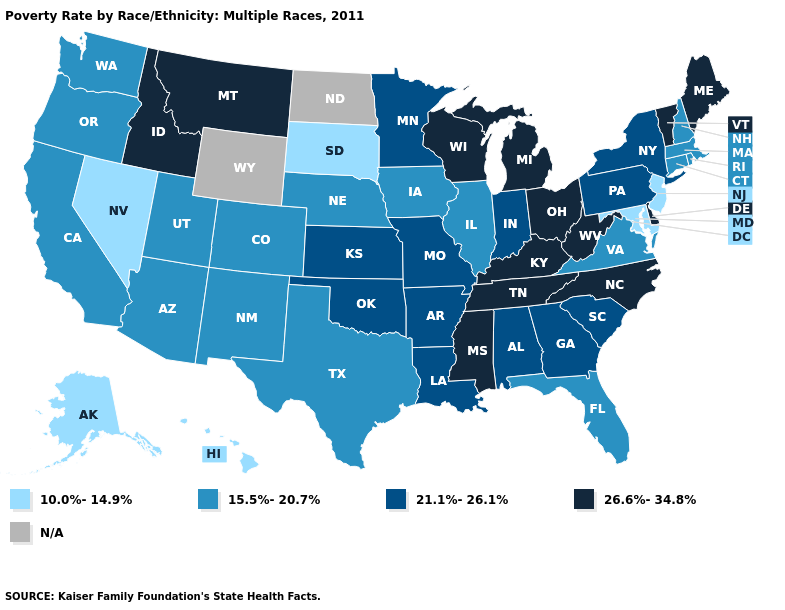Name the states that have a value in the range 10.0%-14.9%?
Write a very short answer. Alaska, Hawaii, Maryland, Nevada, New Jersey, South Dakota. Name the states that have a value in the range 21.1%-26.1%?
Give a very brief answer. Alabama, Arkansas, Georgia, Indiana, Kansas, Louisiana, Minnesota, Missouri, New York, Oklahoma, Pennsylvania, South Carolina. Which states have the lowest value in the USA?
Be succinct. Alaska, Hawaii, Maryland, Nevada, New Jersey, South Dakota. What is the lowest value in states that border New York?
Answer briefly. 10.0%-14.9%. Does Illinois have the highest value in the USA?
Short answer required. No. Among the states that border Florida , which have the lowest value?
Answer briefly. Alabama, Georgia. What is the value of New Hampshire?
Write a very short answer. 15.5%-20.7%. Name the states that have a value in the range 15.5%-20.7%?
Be succinct. Arizona, California, Colorado, Connecticut, Florida, Illinois, Iowa, Massachusetts, Nebraska, New Hampshire, New Mexico, Oregon, Rhode Island, Texas, Utah, Virginia, Washington. What is the lowest value in the USA?
Give a very brief answer. 10.0%-14.9%. Does the first symbol in the legend represent the smallest category?
Short answer required. Yes. What is the value of New Jersey?
Give a very brief answer. 10.0%-14.9%. Which states have the lowest value in the USA?
Keep it brief. Alaska, Hawaii, Maryland, Nevada, New Jersey, South Dakota. Name the states that have a value in the range 26.6%-34.8%?
Answer briefly. Delaware, Idaho, Kentucky, Maine, Michigan, Mississippi, Montana, North Carolina, Ohio, Tennessee, Vermont, West Virginia, Wisconsin. 